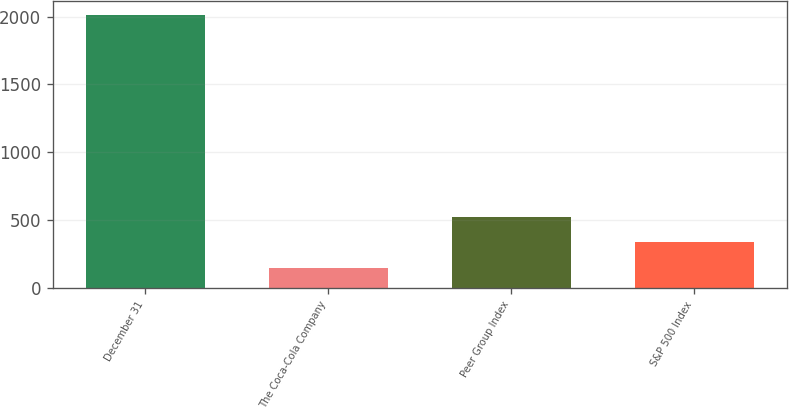<chart> <loc_0><loc_0><loc_500><loc_500><bar_chart><fcel>December 31<fcel>The Coca-Cola Company<fcel>Peer Group Index<fcel>S&P 500 Index<nl><fcel>2015<fcel>151<fcel>523.8<fcel>337.4<nl></chart> 